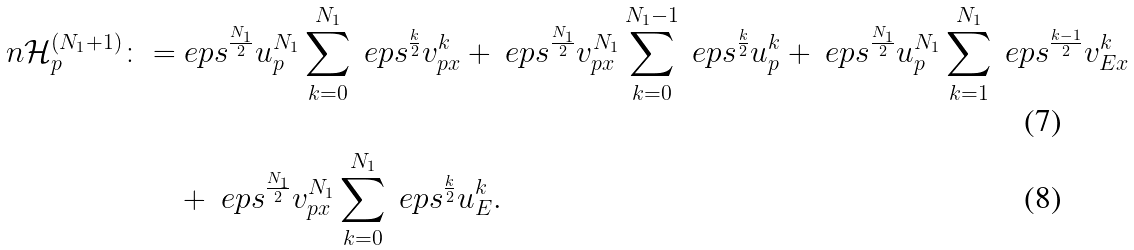<formula> <loc_0><loc_0><loc_500><loc_500>\ n \mathcal { H } _ { p } ^ { ( N _ { 1 } + 1 ) } \colon = & \ e p s ^ { \frac { N _ { 1 } } { 2 } } u ^ { N _ { 1 } } _ { p } \sum _ { k = 0 } ^ { N _ { 1 } } \ e p s ^ { \frac { k } { 2 } } v ^ { k } _ { p x } + \ e p s ^ { \frac { N _ { 1 } } { 2 } } v ^ { N _ { 1 } } _ { p x } \sum _ { k = 0 } ^ { N _ { 1 } - 1 } \ e p s ^ { \frac { k } { 2 } } u ^ { k } _ { p } + \ e p s ^ { \frac { N _ { 1 } } { 2 } } u ^ { N _ { 1 } } _ { p } \sum _ { k = 1 } ^ { N _ { 1 } } \ e p s ^ { \frac { k - 1 } { 2 } } v ^ { k } _ { E x } \\ & + \ e p s ^ { \frac { N _ { 1 } } { 2 } } v ^ { N _ { 1 } } _ { p x } \sum _ { k = 0 } ^ { N _ { 1 } } \ e p s ^ { \frac { k } { 2 } } u ^ { k } _ { E } .</formula> 